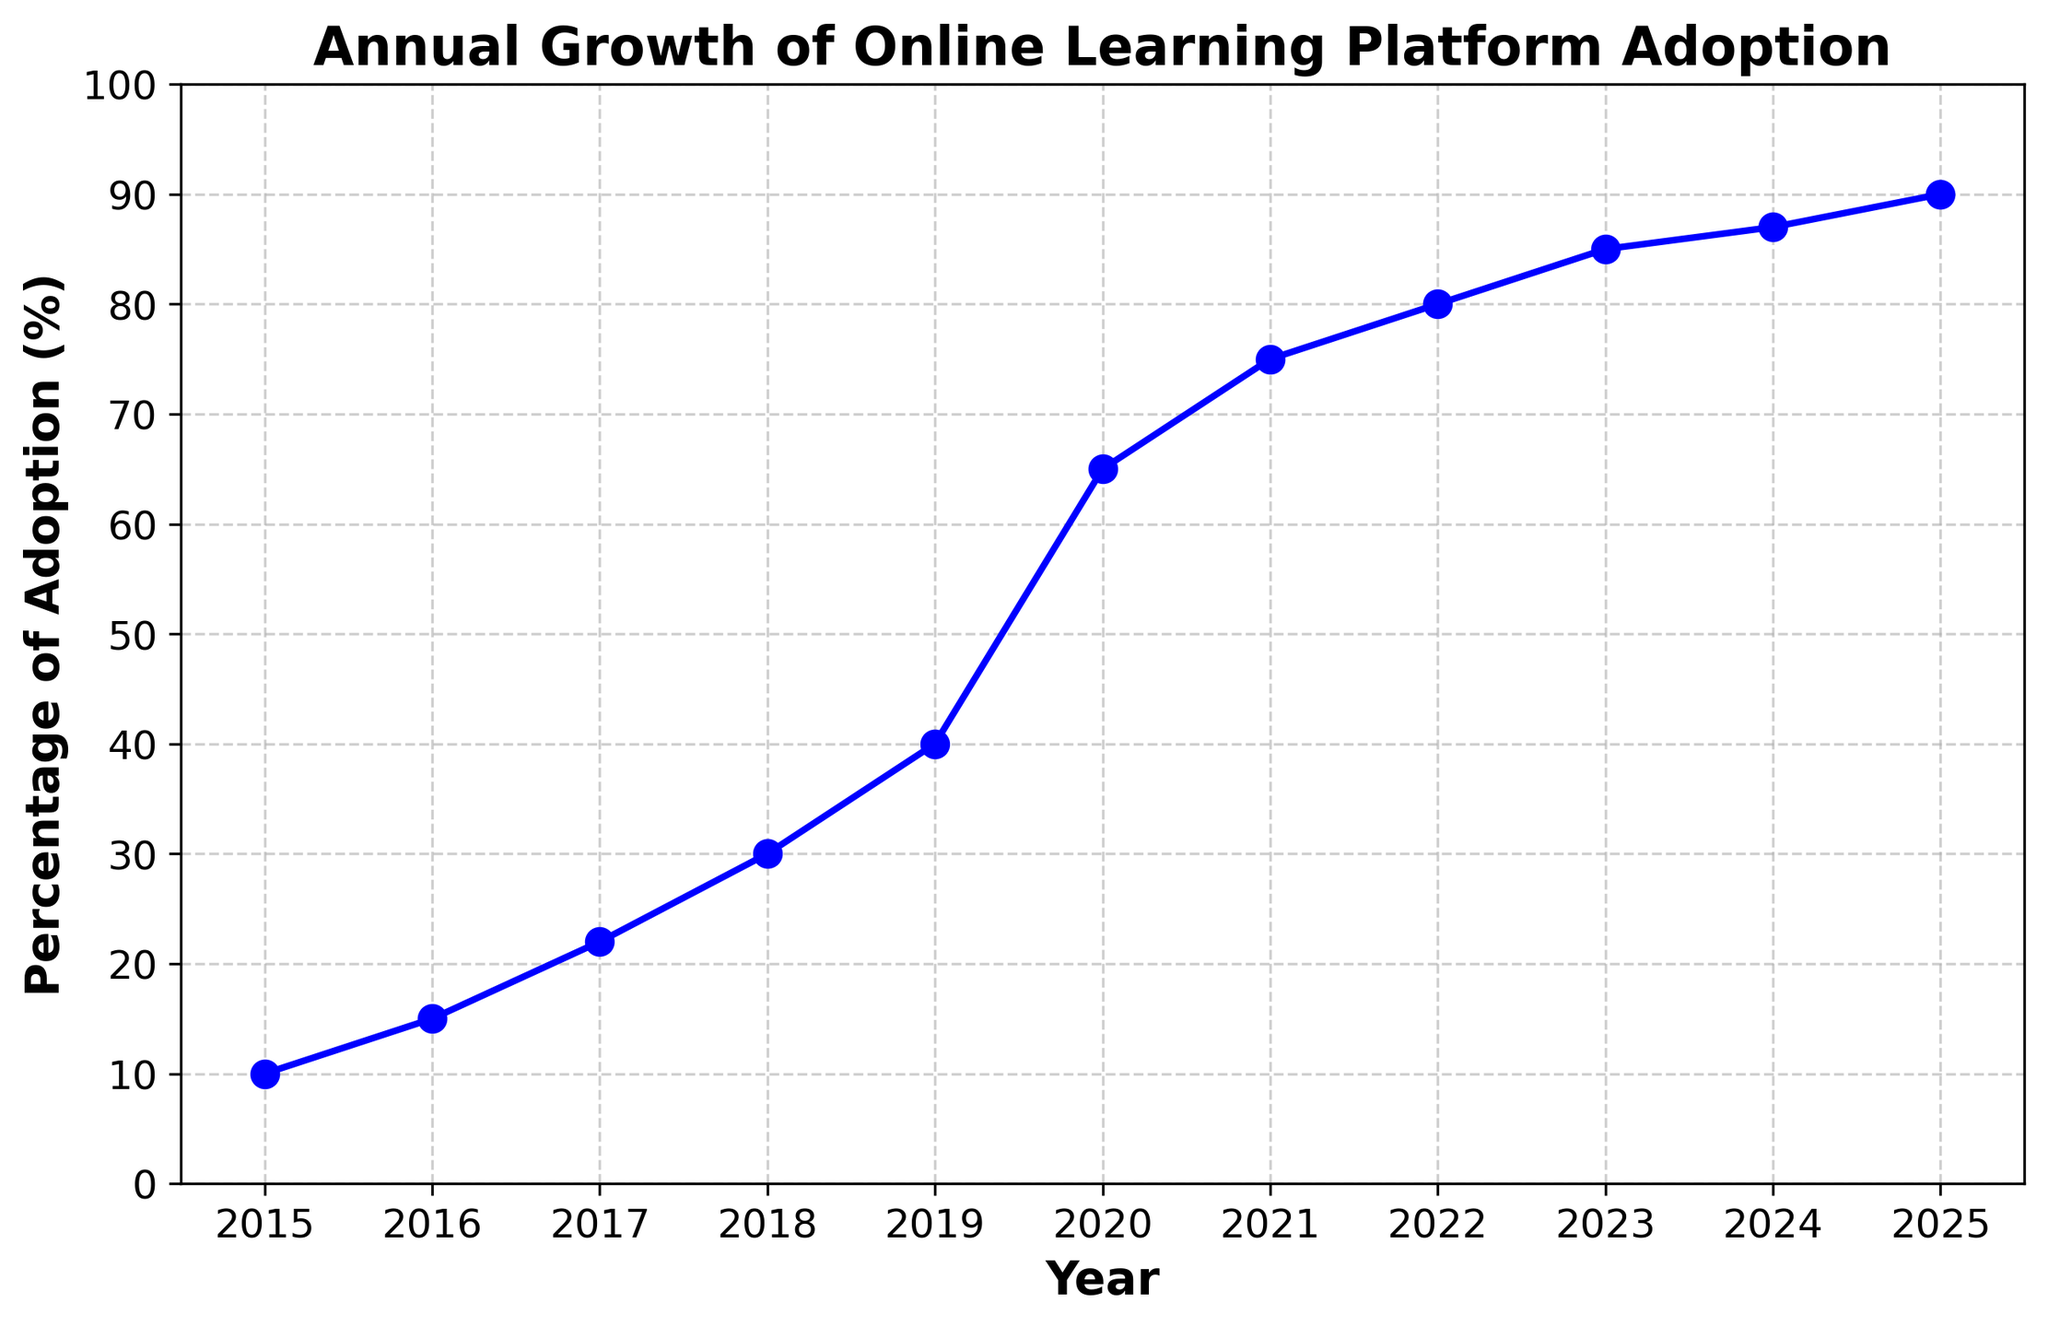What is the percentage adoption in 2020? Locate the point corresponding to the year 2020 on the x-axis and check the percentage adoption value on the y-axis. The value is 65%.
Answer: 65% In which year did the percentage adoption cross the 50% mark? Find the year on the x-axis when the y-axis value is greater than 50. It crossed 50% in 2020.
Answer: 2020 What is the difference in adoption percentage between 2017 and 2019? Locate the percentage adoption values for 2017 and 2019, which are 22% and 40%, respectively. Subtract 22 from 40 to get 18.
Answer: 18% What is the overall trend observed in the plot? The plot shows an increasing trend in the percentage adoption of online learning platforms from 2015 to 2025.
Answer: Increasing Which year shows the highest increase in percentage adoption compared to the previous year? Check the year-over-year increments: largest increase is between 2019 (40%) and 2020 (65%). Increase is 25%.
Answer: 2020 What percentage adoption is projected for 2025? Locate the point corresponding to the year 2025 on the x-axis; the percentage adoption value on the y-axis is 90%.
Answer: 90% Between which consecutive years did the adoption percentage increase the least? Check the year-over-year increments: least increase is between 2024 (87%) and 2025 (90%). Increase is 3%.
Answer: 2024 and 2025 What is the average adoption rate from 2015 to 2025? Sum the adoption values and divide by the total number of years: (10+15+22+30+40+65+75+80+85+87+90)/11 = 55.82 (approx).
Answer: 55.82% What was the adoption percentage in 2018 and how does it compare to the adoption percentage in 2023? Locate adoption for 2018 (30%) and 2023 (85%). Subtract 30 from 85 to get an increase of 55.
Answer: 55% How many years did it take for adoption to increase from 15% to 75%? Identify years corresponding to 15% (2016) and 75% (2021); subtract 2016 from 2021 to find it took 5 years.
Answer: 5 years 